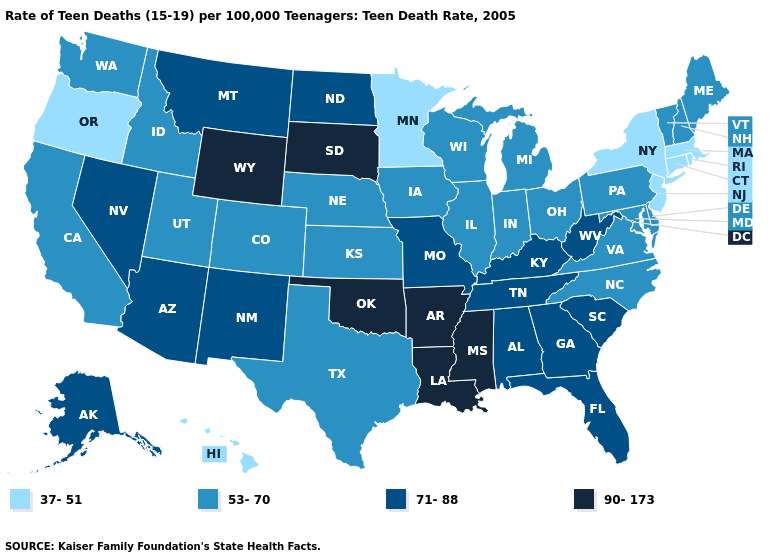Name the states that have a value in the range 90-173?
Give a very brief answer. Arkansas, Louisiana, Mississippi, Oklahoma, South Dakota, Wyoming. Name the states that have a value in the range 37-51?
Be succinct. Connecticut, Hawaii, Massachusetts, Minnesota, New Jersey, New York, Oregon, Rhode Island. Name the states that have a value in the range 71-88?
Answer briefly. Alabama, Alaska, Arizona, Florida, Georgia, Kentucky, Missouri, Montana, Nevada, New Mexico, North Dakota, South Carolina, Tennessee, West Virginia. What is the value of Virginia?
Keep it brief. 53-70. What is the highest value in states that border Nevada?
Keep it brief. 71-88. Among the states that border Tennessee , does Alabama have the lowest value?
Concise answer only. No. Is the legend a continuous bar?
Quick response, please. No. Does the map have missing data?
Short answer required. No. Is the legend a continuous bar?
Concise answer only. No. Name the states that have a value in the range 90-173?
Concise answer only. Arkansas, Louisiana, Mississippi, Oklahoma, South Dakota, Wyoming. What is the highest value in states that border California?
Concise answer only. 71-88. Which states hav the highest value in the South?
Short answer required. Arkansas, Louisiana, Mississippi, Oklahoma. What is the value of West Virginia?
Be succinct. 71-88. Name the states that have a value in the range 71-88?
Write a very short answer. Alabama, Alaska, Arizona, Florida, Georgia, Kentucky, Missouri, Montana, Nevada, New Mexico, North Dakota, South Carolina, Tennessee, West Virginia. Name the states that have a value in the range 90-173?
Give a very brief answer. Arkansas, Louisiana, Mississippi, Oklahoma, South Dakota, Wyoming. 